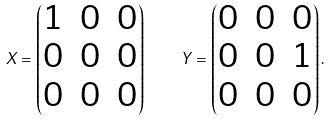<formula> <loc_0><loc_0><loc_500><loc_500>X = \begin{pmatrix} 1 & 0 & 0 \\ 0 & 0 & 0 \\ 0 & 0 & 0 \end{pmatrix} \quad Y = \begin{pmatrix} 0 & 0 & 0 \\ 0 & 0 & 1 \\ 0 & 0 & 0 \end{pmatrix} .</formula> 